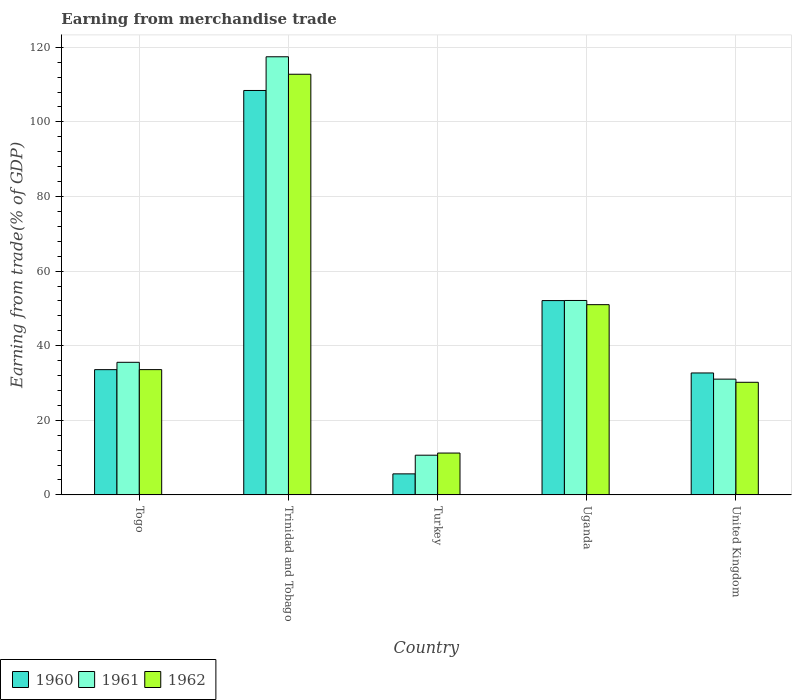How many different coloured bars are there?
Provide a short and direct response. 3. How many groups of bars are there?
Provide a succinct answer. 5. Are the number of bars on each tick of the X-axis equal?
Keep it short and to the point. Yes. How many bars are there on the 2nd tick from the left?
Provide a succinct answer. 3. What is the earnings from trade in 1960 in Uganda?
Ensure brevity in your answer.  52.09. Across all countries, what is the maximum earnings from trade in 1960?
Your response must be concise. 108.42. Across all countries, what is the minimum earnings from trade in 1961?
Ensure brevity in your answer.  10.64. In which country was the earnings from trade in 1962 maximum?
Ensure brevity in your answer.  Trinidad and Tobago. What is the total earnings from trade in 1962 in the graph?
Give a very brief answer. 238.76. What is the difference between the earnings from trade in 1960 in Trinidad and Tobago and that in United Kingdom?
Your answer should be compact. 75.73. What is the difference between the earnings from trade in 1961 in United Kingdom and the earnings from trade in 1960 in Togo?
Provide a succinct answer. -2.54. What is the average earnings from trade in 1960 per country?
Keep it short and to the point. 46.48. What is the difference between the earnings from trade of/in 1960 and earnings from trade of/in 1962 in Turkey?
Provide a succinct answer. -5.58. In how many countries, is the earnings from trade in 1962 greater than 116 %?
Your response must be concise. 0. What is the ratio of the earnings from trade in 1960 in Uganda to that in United Kingdom?
Offer a very short reply. 1.59. Is the earnings from trade in 1961 in Trinidad and Tobago less than that in Uganda?
Offer a terse response. No. What is the difference between the highest and the second highest earnings from trade in 1960?
Provide a succinct answer. -74.84. What is the difference between the highest and the lowest earnings from trade in 1961?
Make the answer very short. 106.81. In how many countries, is the earnings from trade in 1962 greater than the average earnings from trade in 1962 taken over all countries?
Your answer should be very brief. 2. What does the 3rd bar from the right in Togo represents?
Keep it short and to the point. 1960. Is it the case that in every country, the sum of the earnings from trade in 1960 and earnings from trade in 1962 is greater than the earnings from trade in 1961?
Provide a short and direct response. Yes. Are all the bars in the graph horizontal?
Provide a short and direct response. No. How many countries are there in the graph?
Give a very brief answer. 5. Does the graph contain any zero values?
Make the answer very short. No. Where does the legend appear in the graph?
Your answer should be very brief. Bottom left. How many legend labels are there?
Your answer should be very brief. 3. How are the legend labels stacked?
Provide a short and direct response. Horizontal. What is the title of the graph?
Your response must be concise. Earning from merchandise trade. What is the label or title of the X-axis?
Provide a short and direct response. Country. What is the label or title of the Y-axis?
Keep it short and to the point. Earning from trade(% of GDP). What is the Earning from trade(% of GDP) of 1960 in Togo?
Offer a terse response. 33.58. What is the Earning from trade(% of GDP) in 1961 in Togo?
Your answer should be very brief. 35.55. What is the Earning from trade(% of GDP) of 1962 in Togo?
Your response must be concise. 33.58. What is the Earning from trade(% of GDP) of 1960 in Trinidad and Tobago?
Make the answer very short. 108.42. What is the Earning from trade(% of GDP) in 1961 in Trinidad and Tobago?
Your answer should be compact. 117.45. What is the Earning from trade(% of GDP) of 1962 in Trinidad and Tobago?
Offer a very short reply. 112.77. What is the Earning from trade(% of GDP) of 1960 in Turkey?
Provide a succinct answer. 5.64. What is the Earning from trade(% of GDP) of 1961 in Turkey?
Offer a terse response. 10.64. What is the Earning from trade(% of GDP) in 1962 in Turkey?
Provide a short and direct response. 11.21. What is the Earning from trade(% of GDP) of 1960 in Uganda?
Your answer should be compact. 52.09. What is the Earning from trade(% of GDP) in 1961 in Uganda?
Offer a terse response. 52.12. What is the Earning from trade(% of GDP) of 1962 in Uganda?
Offer a very short reply. 51. What is the Earning from trade(% of GDP) in 1960 in United Kingdom?
Your answer should be very brief. 32.69. What is the Earning from trade(% of GDP) of 1961 in United Kingdom?
Offer a very short reply. 31.04. What is the Earning from trade(% of GDP) in 1962 in United Kingdom?
Your response must be concise. 30.19. Across all countries, what is the maximum Earning from trade(% of GDP) in 1960?
Offer a very short reply. 108.42. Across all countries, what is the maximum Earning from trade(% of GDP) in 1961?
Give a very brief answer. 117.45. Across all countries, what is the maximum Earning from trade(% of GDP) of 1962?
Keep it short and to the point. 112.77. Across all countries, what is the minimum Earning from trade(% of GDP) of 1960?
Ensure brevity in your answer.  5.64. Across all countries, what is the minimum Earning from trade(% of GDP) of 1961?
Offer a very short reply. 10.64. Across all countries, what is the minimum Earning from trade(% of GDP) in 1962?
Keep it short and to the point. 11.21. What is the total Earning from trade(% of GDP) of 1960 in the graph?
Offer a terse response. 232.41. What is the total Earning from trade(% of GDP) in 1961 in the graph?
Your response must be concise. 246.8. What is the total Earning from trade(% of GDP) of 1962 in the graph?
Ensure brevity in your answer.  238.76. What is the difference between the Earning from trade(% of GDP) in 1960 in Togo and that in Trinidad and Tobago?
Your answer should be very brief. -74.84. What is the difference between the Earning from trade(% of GDP) of 1961 in Togo and that in Trinidad and Tobago?
Your answer should be very brief. -81.9. What is the difference between the Earning from trade(% of GDP) in 1962 in Togo and that in Trinidad and Tobago?
Your response must be concise. -79.19. What is the difference between the Earning from trade(% of GDP) of 1960 in Togo and that in Turkey?
Provide a succinct answer. 27.94. What is the difference between the Earning from trade(% of GDP) in 1961 in Togo and that in Turkey?
Offer a very short reply. 24.9. What is the difference between the Earning from trade(% of GDP) of 1962 in Togo and that in Turkey?
Make the answer very short. 22.37. What is the difference between the Earning from trade(% of GDP) in 1960 in Togo and that in Uganda?
Your answer should be compact. -18.51. What is the difference between the Earning from trade(% of GDP) of 1961 in Togo and that in Uganda?
Keep it short and to the point. -16.57. What is the difference between the Earning from trade(% of GDP) in 1962 in Togo and that in Uganda?
Ensure brevity in your answer.  -17.41. What is the difference between the Earning from trade(% of GDP) in 1960 in Togo and that in United Kingdom?
Provide a succinct answer. 0.89. What is the difference between the Earning from trade(% of GDP) in 1961 in Togo and that in United Kingdom?
Your answer should be compact. 4.51. What is the difference between the Earning from trade(% of GDP) of 1962 in Togo and that in United Kingdom?
Make the answer very short. 3.4. What is the difference between the Earning from trade(% of GDP) in 1960 in Trinidad and Tobago and that in Turkey?
Offer a very short reply. 102.78. What is the difference between the Earning from trade(% of GDP) in 1961 in Trinidad and Tobago and that in Turkey?
Keep it short and to the point. 106.81. What is the difference between the Earning from trade(% of GDP) of 1962 in Trinidad and Tobago and that in Turkey?
Offer a very short reply. 101.56. What is the difference between the Earning from trade(% of GDP) of 1960 in Trinidad and Tobago and that in Uganda?
Offer a very short reply. 56.33. What is the difference between the Earning from trade(% of GDP) in 1961 in Trinidad and Tobago and that in Uganda?
Your response must be concise. 65.33. What is the difference between the Earning from trade(% of GDP) of 1962 in Trinidad and Tobago and that in Uganda?
Provide a succinct answer. 61.77. What is the difference between the Earning from trade(% of GDP) of 1960 in Trinidad and Tobago and that in United Kingdom?
Keep it short and to the point. 75.73. What is the difference between the Earning from trade(% of GDP) of 1961 in Trinidad and Tobago and that in United Kingdom?
Your response must be concise. 86.42. What is the difference between the Earning from trade(% of GDP) in 1962 in Trinidad and Tobago and that in United Kingdom?
Offer a very short reply. 82.58. What is the difference between the Earning from trade(% of GDP) of 1960 in Turkey and that in Uganda?
Ensure brevity in your answer.  -46.45. What is the difference between the Earning from trade(% of GDP) in 1961 in Turkey and that in Uganda?
Keep it short and to the point. -41.48. What is the difference between the Earning from trade(% of GDP) in 1962 in Turkey and that in Uganda?
Offer a terse response. -39.78. What is the difference between the Earning from trade(% of GDP) of 1960 in Turkey and that in United Kingdom?
Provide a short and direct response. -27.05. What is the difference between the Earning from trade(% of GDP) in 1961 in Turkey and that in United Kingdom?
Ensure brevity in your answer.  -20.39. What is the difference between the Earning from trade(% of GDP) of 1962 in Turkey and that in United Kingdom?
Make the answer very short. -18.97. What is the difference between the Earning from trade(% of GDP) of 1960 in Uganda and that in United Kingdom?
Provide a succinct answer. 19.4. What is the difference between the Earning from trade(% of GDP) in 1961 in Uganda and that in United Kingdom?
Your answer should be very brief. 21.08. What is the difference between the Earning from trade(% of GDP) of 1962 in Uganda and that in United Kingdom?
Offer a very short reply. 20.81. What is the difference between the Earning from trade(% of GDP) of 1960 in Togo and the Earning from trade(% of GDP) of 1961 in Trinidad and Tobago?
Ensure brevity in your answer.  -83.87. What is the difference between the Earning from trade(% of GDP) of 1960 in Togo and the Earning from trade(% of GDP) of 1962 in Trinidad and Tobago?
Your answer should be compact. -79.19. What is the difference between the Earning from trade(% of GDP) in 1961 in Togo and the Earning from trade(% of GDP) in 1962 in Trinidad and Tobago?
Make the answer very short. -77.23. What is the difference between the Earning from trade(% of GDP) in 1960 in Togo and the Earning from trade(% of GDP) in 1961 in Turkey?
Ensure brevity in your answer.  22.93. What is the difference between the Earning from trade(% of GDP) of 1960 in Togo and the Earning from trade(% of GDP) of 1962 in Turkey?
Ensure brevity in your answer.  22.36. What is the difference between the Earning from trade(% of GDP) in 1961 in Togo and the Earning from trade(% of GDP) in 1962 in Turkey?
Your response must be concise. 24.33. What is the difference between the Earning from trade(% of GDP) in 1960 in Togo and the Earning from trade(% of GDP) in 1961 in Uganda?
Your response must be concise. -18.54. What is the difference between the Earning from trade(% of GDP) of 1960 in Togo and the Earning from trade(% of GDP) of 1962 in Uganda?
Make the answer very short. -17.42. What is the difference between the Earning from trade(% of GDP) in 1961 in Togo and the Earning from trade(% of GDP) in 1962 in Uganda?
Make the answer very short. -15.45. What is the difference between the Earning from trade(% of GDP) in 1960 in Togo and the Earning from trade(% of GDP) in 1961 in United Kingdom?
Provide a short and direct response. 2.54. What is the difference between the Earning from trade(% of GDP) in 1960 in Togo and the Earning from trade(% of GDP) in 1962 in United Kingdom?
Provide a succinct answer. 3.39. What is the difference between the Earning from trade(% of GDP) in 1961 in Togo and the Earning from trade(% of GDP) in 1962 in United Kingdom?
Provide a succinct answer. 5.36. What is the difference between the Earning from trade(% of GDP) in 1960 in Trinidad and Tobago and the Earning from trade(% of GDP) in 1961 in Turkey?
Provide a short and direct response. 97.77. What is the difference between the Earning from trade(% of GDP) in 1960 in Trinidad and Tobago and the Earning from trade(% of GDP) in 1962 in Turkey?
Offer a very short reply. 97.2. What is the difference between the Earning from trade(% of GDP) in 1961 in Trinidad and Tobago and the Earning from trade(% of GDP) in 1962 in Turkey?
Your response must be concise. 106.24. What is the difference between the Earning from trade(% of GDP) of 1960 in Trinidad and Tobago and the Earning from trade(% of GDP) of 1961 in Uganda?
Offer a terse response. 56.3. What is the difference between the Earning from trade(% of GDP) in 1960 in Trinidad and Tobago and the Earning from trade(% of GDP) in 1962 in Uganda?
Your answer should be very brief. 57.42. What is the difference between the Earning from trade(% of GDP) of 1961 in Trinidad and Tobago and the Earning from trade(% of GDP) of 1962 in Uganda?
Ensure brevity in your answer.  66.45. What is the difference between the Earning from trade(% of GDP) in 1960 in Trinidad and Tobago and the Earning from trade(% of GDP) in 1961 in United Kingdom?
Offer a very short reply. 77.38. What is the difference between the Earning from trade(% of GDP) in 1960 in Trinidad and Tobago and the Earning from trade(% of GDP) in 1962 in United Kingdom?
Give a very brief answer. 78.23. What is the difference between the Earning from trade(% of GDP) in 1961 in Trinidad and Tobago and the Earning from trade(% of GDP) in 1962 in United Kingdom?
Provide a succinct answer. 87.26. What is the difference between the Earning from trade(% of GDP) in 1960 in Turkey and the Earning from trade(% of GDP) in 1961 in Uganda?
Offer a very short reply. -46.48. What is the difference between the Earning from trade(% of GDP) of 1960 in Turkey and the Earning from trade(% of GDP) of 1962 in Uganda?
Your response must be concise. -45.36. What is the difference between the Earning from trade(% of GDP) in 1961 in Turkey and the Earning from trade(% of GDP) in 1962 in Uganda?
Keep it short and to the point. -40.35. What is the difference between the Earning from trade(% of GDP) of 1960 in Turkey and the Earning from trade(% of GDP) of 1961 in United Kingdom?
Offer a very short reply. -25.4. What is the difference between the Earning from trade(% of GDP) in 1960 in Turkey and the Earning from trade(% of GDP) in 1962 in United Kingdom?
Ensure brevity in your answer.  -24.55. What is the difference between the Earning from trade(% of GDP) in 1961 in Turkey and the Earning from trade(% of GDP) in 1962 in United Kingdom?
Make the answer very short. -19.54. What is the difference between the Earning from trade(% of GDP) of 1960 in Uganda and the Earning from trade(% of GDP) of 1961 in United Kingdom?
Your answer should be very brief. 21.05. What is the difference between the Earning from trade(% of GDP) of 1960 in Uganda and the Earning from trade(% of GDP) of 1962 in United Kingdom?
Provide a short and direct response. 21.9. What is the difference between the Earning from trade(% of GDP) in 1961 in Uganda and the Earning from trade(% of GDP) in 1962 in United Kingdom?
Offer a terse response. 21.93. What is the average Earning from trade(% of GDP) of 1960 per country?
Make the answer very short. 46.48. What is the average Earning from trade(% of GDP) of 1961 per country?
Your response must be concise. 49.36. What is the average Earning from trade(% of GDP) of 1962 per country?
Your answer should be very brief. 47.75. What is the difference between the Earning from trade(% of GDP) in 1960 and Earning from trade(% of GDP) in 1961 in Togo?
Your answer should be very brief. -1.97. What is the difference between the Earning from trade(% of GDP) of 1960 and Earning from trade(% of GDP) of 1962 in Togo?
Ensure brevity in your answer.  -0.01. What is the difference between the Earning from trade(% of GDP) of 1961 and Earning from trade(% of GDP) of 1962 in Togo?
Make the answer very short. 1.96. What is the difference between the Earning from trade(% of GDP) of 1960 and Earning from trade(% of GDP) of 1961 in Trinidad and Tobago?
Keep it short and to the point. -9.03. What is the difference between the Earning from trade(% of GDP) of 1960 and Earning from trade(% of GDP) of 1962 in Trinidad and Tobago?
Your response must be concise. -4.35. What is the difference between the Earning from trade(% of GDP) in 1961 and Earning from trade(% of GDP) in 1962 in Trinidad and Tobago?
Give a very brief answer. 4.68. What is the difference between the Earning from trade(% of GDP) of 1960 and Earning from trade(% of GDP) of 1961 in Turkey?
Your answer should be very brief. -5.01. What is the difference between the Earning from trade(% of GDP) in 1960 and Earning from trade(% of GDP) in 1962 in Turkey?
Your response must be concise. -5.58. What is the difference between the Earning from trade(% of GDP) of 1961 and Earning from trade(% of GDP) of 1962 in Turkey?
Give a very brief answer. -0.57. What is the difference between the Earning from trade(% of GDP) in 1960 and Earning from trade(% of GDP) in 1961 in Uganda?
Give a very brief answer. -0.03. What is the difference between the Earning from trade(% of GDP) in 1960 and Earning from trade(% of GDP) in 1962 in Uganda?
Offer a terse response. 1.09. What is the difference between the Earning from trade(% of GDP) in 1961 and Earning from trade(% of GDP) in 1962 in Uganda?
Your answer should be compact. 1.12. What is the difference between the Earning from trade(% of GDP) of 1960 and Earning from trade(% of GDP) of 1961 in United Kingdom?
Your answer should be compact. 1.65. What is the difference between the Earning from trade(% of GDP) in 1960 and Earning from trade(% of GDP) in 1962 in United Kingdom?
Give a very brief answer. 2.5. What is the difference between the Earning from trade(% of GDP) of 1961 and Earning from trade(% of GDP) of 1962 in United Kingdom?
Your answer should be compact. 0.85. What is the ratio of the Earning from trade(% of GDP) of 1960 in Togo to that in Trinidad and Tobago?
Your answer should be very brief. 0.31. What is the ratio of the Earning from trade(% of GDP) in 1961 in Togo to that in Trinidad and Tobago?
Your answer should be very brief. 0.3. What is the ratio of the Earning from trade(% of GDP) of 1962 in Togo to that in Trinidad and Tobago?
Offer a very short reply. 0.3. What is the ratio of the Earning from trade(% of GDP) in 1960 in Togo to that in Turkey?
Keep it short and to the point. 5.96. What is the ratio of the Earning from trade(% of GDP) of 1961 in Togo to that in Turkey?
Keep it short and to the point. 3.34. What is the ratio of the Earning from trade(% of GDP) of 1962 in Togo to that in Turkey?
Ensure brevity in your answer.  2.99. What is the ratio of the Earning from trade(% of GDP) of 1960 in Togo to that in Uganda?
Offer a very short reply. 0.64. What is the ratio of the Earning from trade(% of GDP) of 1961 in Togo to that in Uganda?
Your answer should be very brief. 0.68. What is the ratio of the Earning from trade(% of GDP) of 1962 in Togo to that in Uganda?
Your response must be concise. 0.66. What is the ratio of the Earning from trade(% of GDP) of 1960 in Togo to that in United Kingdom?
Offer a terse response. 1.03. What is the ratio of the Earning from trade(% of GDP) in 1961 in Togo to that in United Kingdom?
Provide a short and direct response. 1.15. What is the ratio of the Earning from trade(% of GDP) of 1962 in Togo to that in United Kingdom?
Provide a short and direct response. 1.11. What is the ratio of the Earning from trade(% of GDP) of 1960 in Trinidad and Tobago to that in Turkey?
Your response must be concise. 19.23. What is the ratio of the Earning from trade(% of GDP) of 1961 in Trinidad and Tobago to that in Turkey?
Keep it short and to the point. 11.03. What is the ratio of the Earning from trade(% of GDP) in 1962 in Trinidad and Tobago to that in Turkey?
Offer a terse response. 10.06. What is the ratio of the Earning from trade(% of GDP) in 1960 in Trinidad and Tobago to that in Uganda?
Your response must be concise. 2.08. What is the ratio of the Earning from trade(% of GDP) of 1961 in Trinidad and Tobago to that in Uganda?
Your response must be concise. 2.25. What is the ratio of the Earning from trade(% of GDP) of 1962 in Trinidad and Tobago to that in Uganda?
Ensure brevity in your answer.  2.21. What is the ratio of the Earning from trade(% of GDP) of 1960 in Trinidad and Tobago to that in United Kingdom?
Your answer should be very brief. 3.32. What is the ratio of the Earning from trade(% of GDP) in 1961 in Trinidad and Tobago to that in United Kingdom?
Provide a short and direct response. 3.78. What is the ratio of the Earning from trade(% of GDP) of 1962 in Trinidad and Tobago to that in United Kingdom?
Keep it short and to the point. 3.74. What is the ratio of the Earning from trade(% of GDP) of 1960 in Turkey to that in Uganda?
Provide a short and direct response. 0.11. What is the ratio of the Earning from trade(% of GDP) in 1961 in Turkey to that in Uganda?
Your response must be concise. 0.2. What is the ratio of the Earning from trade(% of GDP) in 1962 in Turkey to that in Uganda?
Give a very brief answer. 0.22. What is the ratio of the Earning from trade(% of GDP) of 1960 in Turkey to that in United Kingdom?
Offer a terse response. 0.17. What is the ratio of the Earning from trade(% of GDP) in 1961 in Turkey to that in United Kingdom?
Keep it short and to the point. 0.34. What is the ratio of the Earning from trade(% of GDP) of 1962 in Turkey to that in United Kingdom?
Your answer should be very brief. 0.37. What is the ratio of the Earning from trade(% of GDP) in 1960 in Uganda to that in United Kingdom?
Your answer should be compact. 1.59. What is the ratio of the Earning from trade(% of GDP) in 1961 in Uganda to that in United Kingdom?
Ensure brevity in your answer.  1.68. What is the ratio of the Earning from trade(% of GDP) of 1962 in Uganda to that in United Kingdom?
Offer a terse response. 1.69. What is the difference between the highest and the second highest Earning from trade(% of GDP) in 1960?
Offer a very short reply. 56.33. What is the difference between the highest and the second highest Earning from trade(% of GDP) of 1961?
Your answer should be compact. 65.33. What is the difference between the highest and the second highest Earning from trade(% of GDP) of 1962?
Your answer should be compact. 61.77. What is the difference between the highest and the lowest Earning from trade(% of GDP) of 1960?
Provide a short and direct response. 102.78. What is the difference between the highest and the lowest Earning from trade(% of GDP) in 1961?
Ensure brevity in your answer.  106.81. What is the difference between the highest and the lowest Earning from trade(% of GDP) of 1962?
Give a very brief answer. 101.56. 